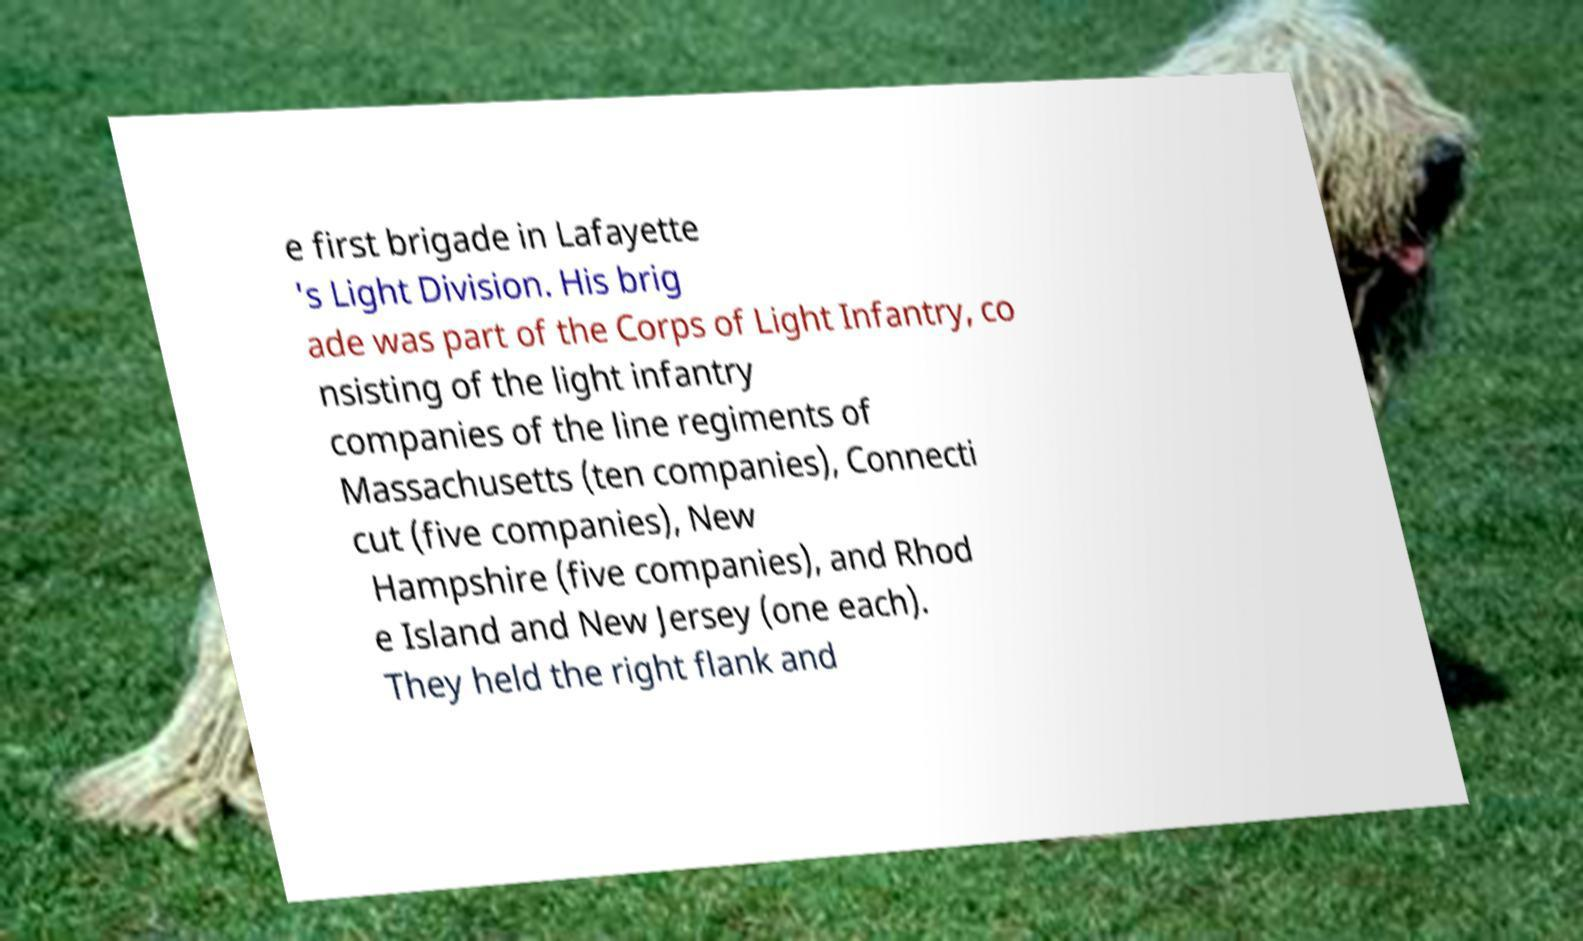There's text embedded in this image that I need extracted. Can you transcribe it verbatim? e first brigade in Lafayette 's Light Division. His brig ade was part of the Corps of Light Infantry, co nsisting of the light infantry companies of the line regiments of Massachusetts (ten companies), Connecti cut (five companies), New Hampshire (five companies), and Rhod e Island and New Jersey (one each). They held the right flank and 